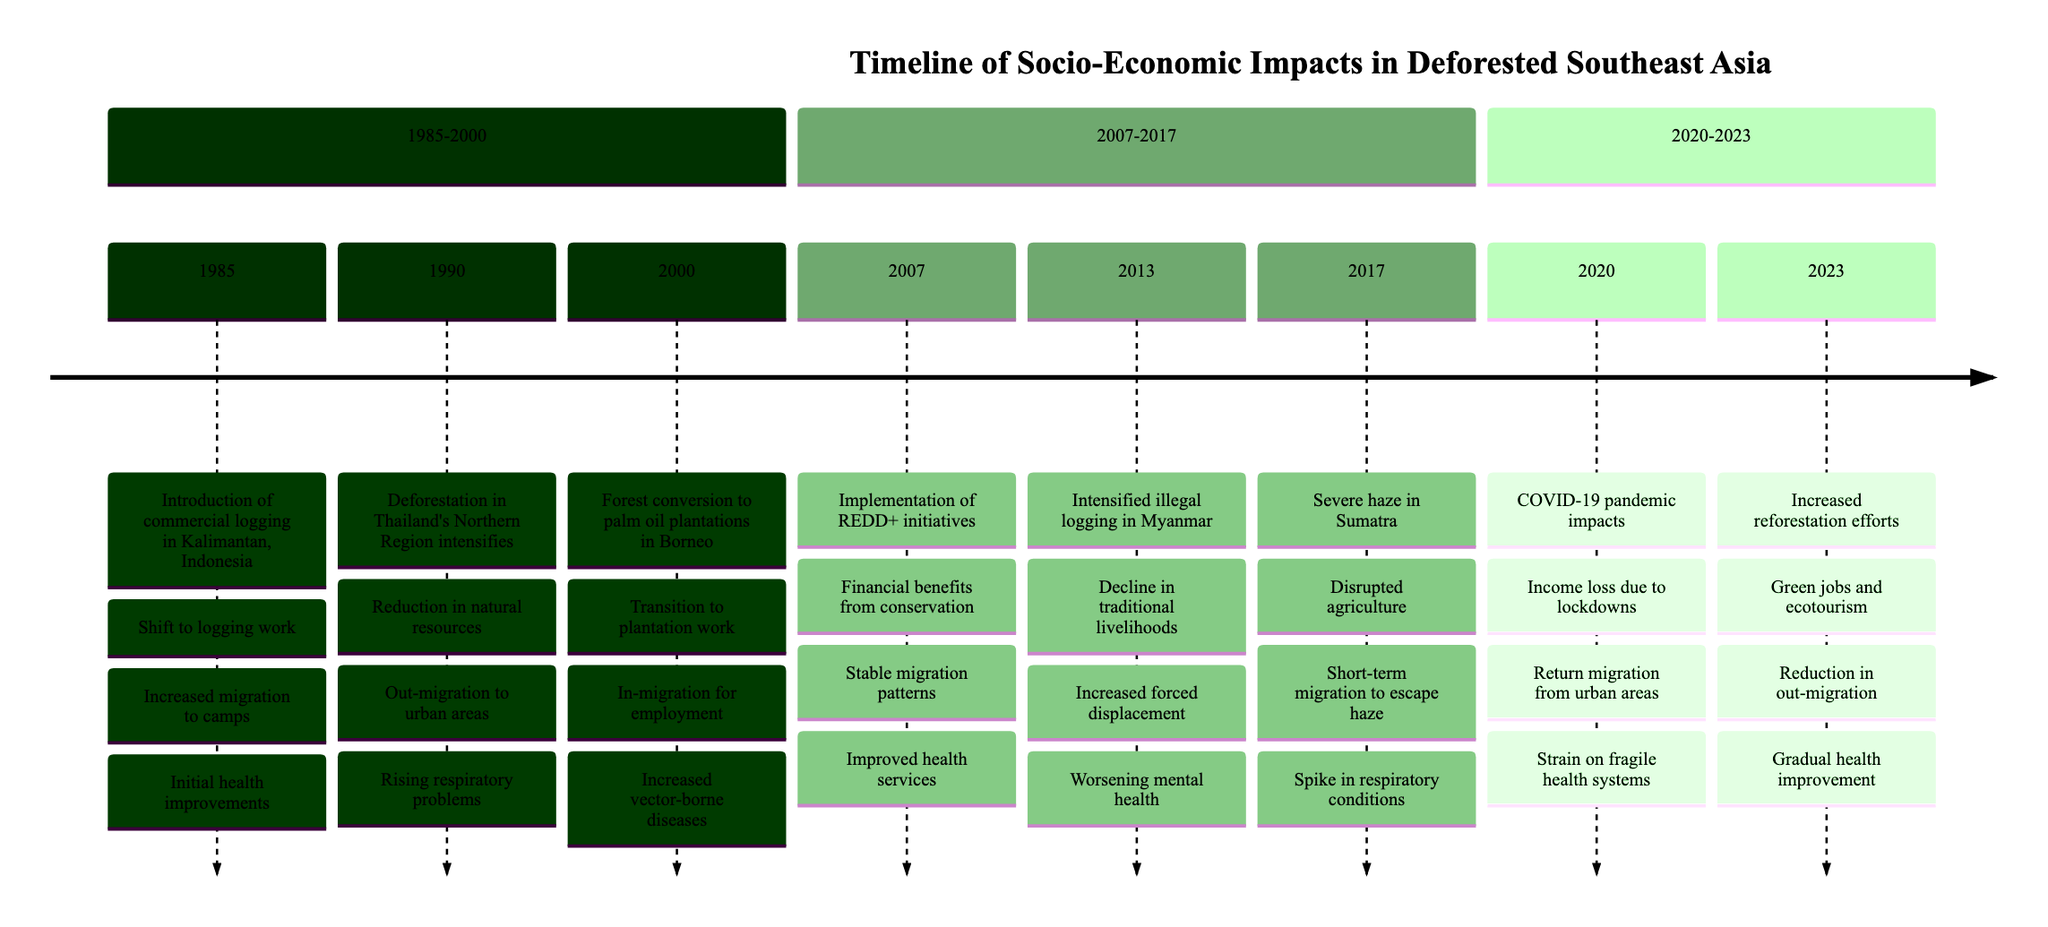What event occurred in 1985? The event listed for 1985 is the introduction of commercial logging in Kalimantan, Indonesia. This is directly mentioned in the timeline section for the year 1985.
Answer: Introduction of commercial logging in Kalimantan, Indonesia What was the impact on livelihood in 2000? In 2000, the impact on livelihood was a transition to plantation-based employment as indicated in the timeline. This reflects the economic shifts occurring during that year.
Answer: Transition to plantation-based employment How did migration patterns change from 1990 to 2013? In 1990, there was out-migration to urban areas for alternative employment, while by 2013, the migration trends included increased forced displacement due to intensified illegal logging activities. This shows a shift from voluntary to more distress-driven migration patterns over time.
Answer: Increased forced displacement What health issue spiked in 2017? The timeline clearly states that in 2017, there was a spike in respiratory and cardiovascular conditions due to severe haze in Sumatra, highlighting the health crisis faced during that year.
Answer: Spike in respiratory and cardiovascular conditions What financial benefit arose from REDD+ initiatives in 2007? The timeline notes that in 2007, the implementation of REDD+ initiatives resulted in financial benefits from conservation projects which directly relates to economic improvements for local communities.
Answer: Financial benefits from conservation projects How did the COVID-19 pandemic impact migration patterns in 2020? The impact mentioned in the timeline for 2020 indicates a return migration due to job losses in urban areas, highlighting how the pandemic affected people's movement and employment drastically.
Answer: Return migration due to job losses in urban areas What was noted about health outcomes by 2023? By 2023, the timeline states that there was a gradual improvement in community health outcomes, indicating positive health trends in the aftermath of socio-economic changes and reforestation efforts.
Answer: Gradual improvement in community health outcomes What livelihood change occurred between 2013 and 2017? The timeline indicates that between 2013 and 2017, there was a further decline in traditional livelihoods due to intensified illegal logging, leading to reduced economic stability for local communities during that period.
Answer: Further decline in traditional livelihoods What happened to agricultural activities in 2017? In 2017, the timeline states that there was a disruption in agricultural activities due to severe haze in Sumatra, thus point toward environmental challenges impacting food production that year.
Answer: Disruption in agricultural activities 